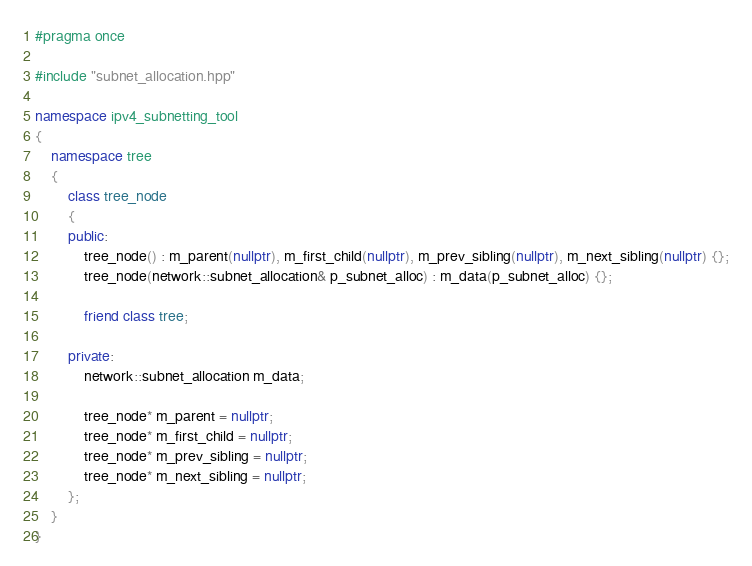Convert code to text. <code><loc_0><loc_0><loc_500><loc_500><_C++_>#pragma once

#include "subnet_allocation.hpp"

namespace ipv4_subnetting_tool
{
	namespace tree
	{
		class tree_node
		{
		public:
			tree_node() : m_parent(nullptr), m_first_child(nullptr), m_prev_sibling(nullptr), m_next_sibling(nullptr) {};
			tree_node(network::subnet_allocation& p_subnet_alloc) : m_data(p_subnet_alloc) {};

			friend class tree;

		private:
			network::subnet_allocation m_data;

			tree_node* m_parent = nullptr;
			tree_node* m_first_child = nullptr;
			tree_node* m_prev_sibling = nullptr;
			tree_node* m_next_sibling = nullptr;
		};
	}
}
</code> 